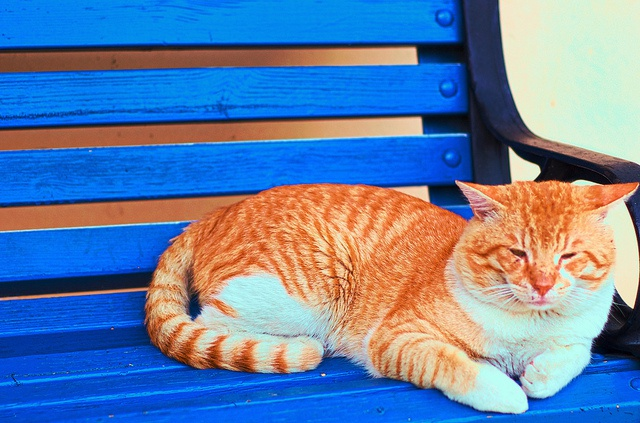Describe the objects in this image and their specific colors. I can see bench in blue, gray, black, and navy tones and cat in blue, tan, red, and lightblue tones in this image. 